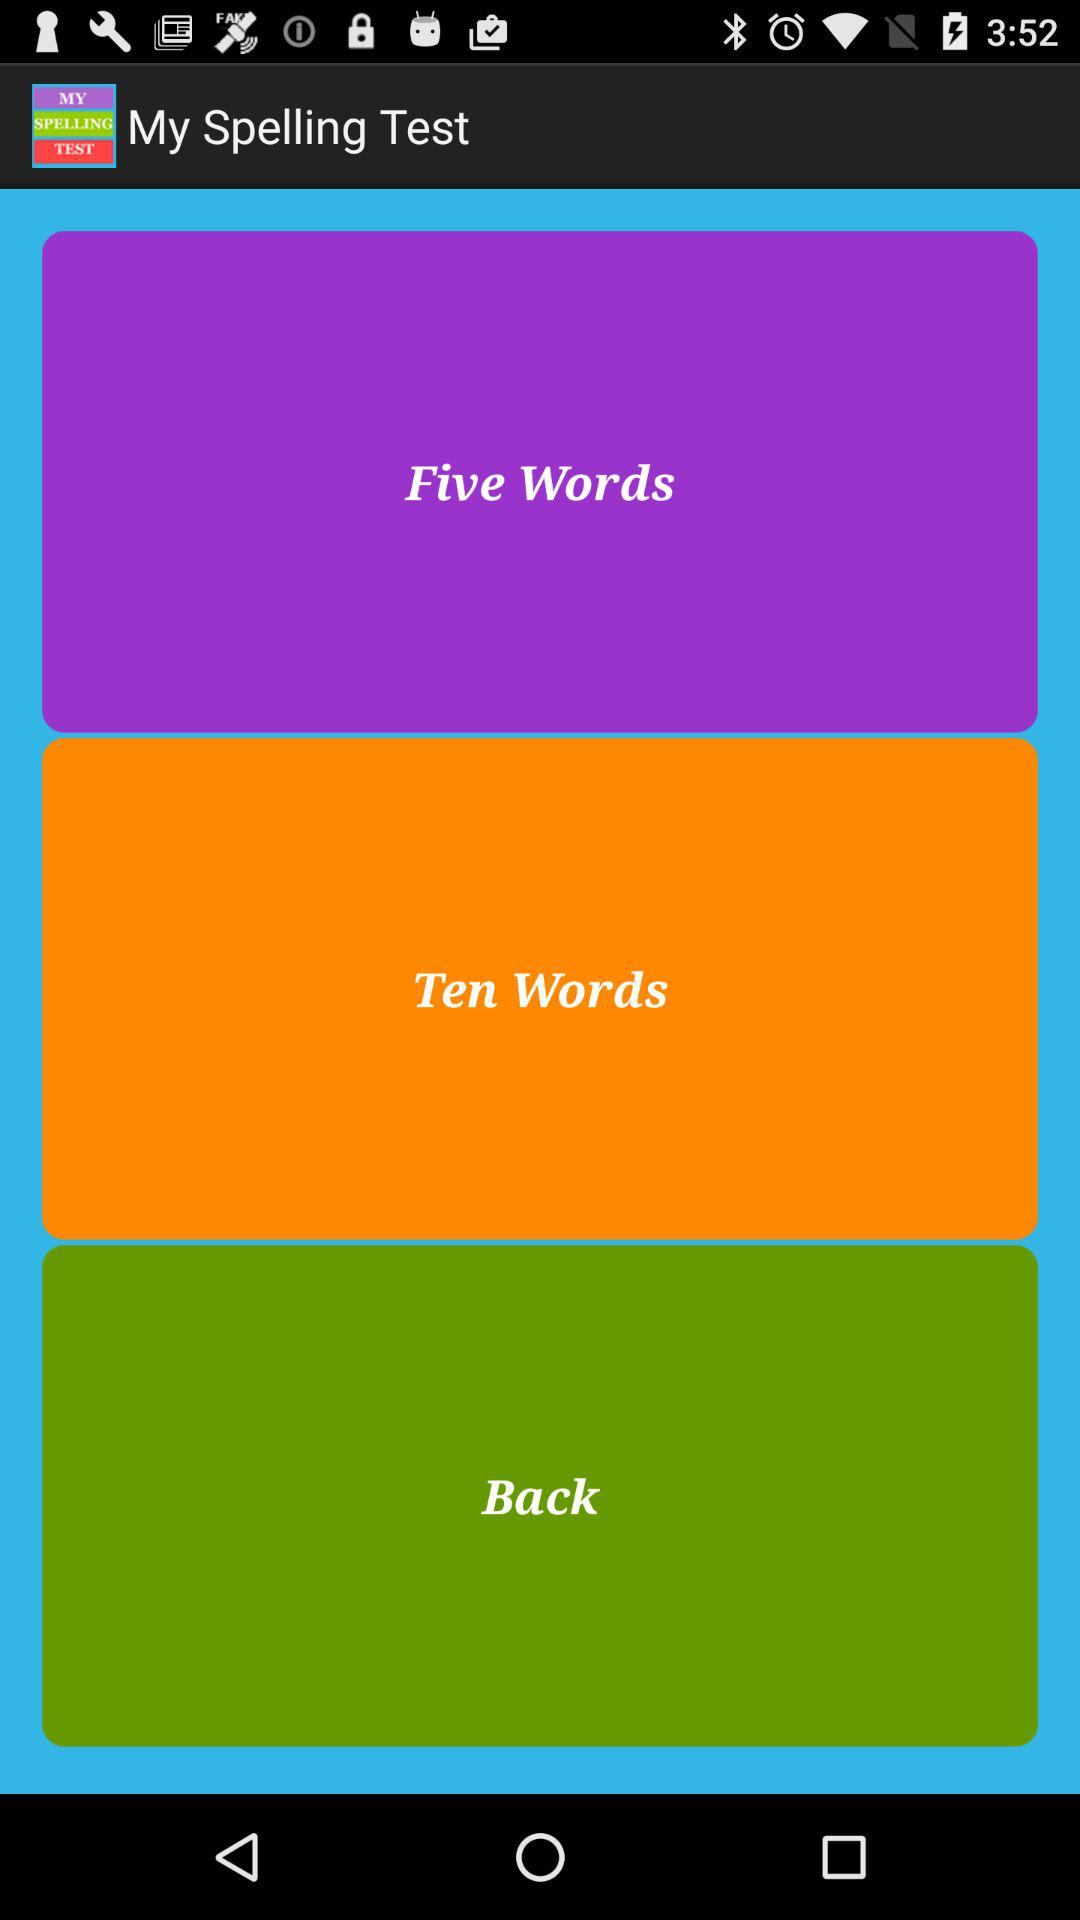What is the application name? The application name is "My Spelling Test". 